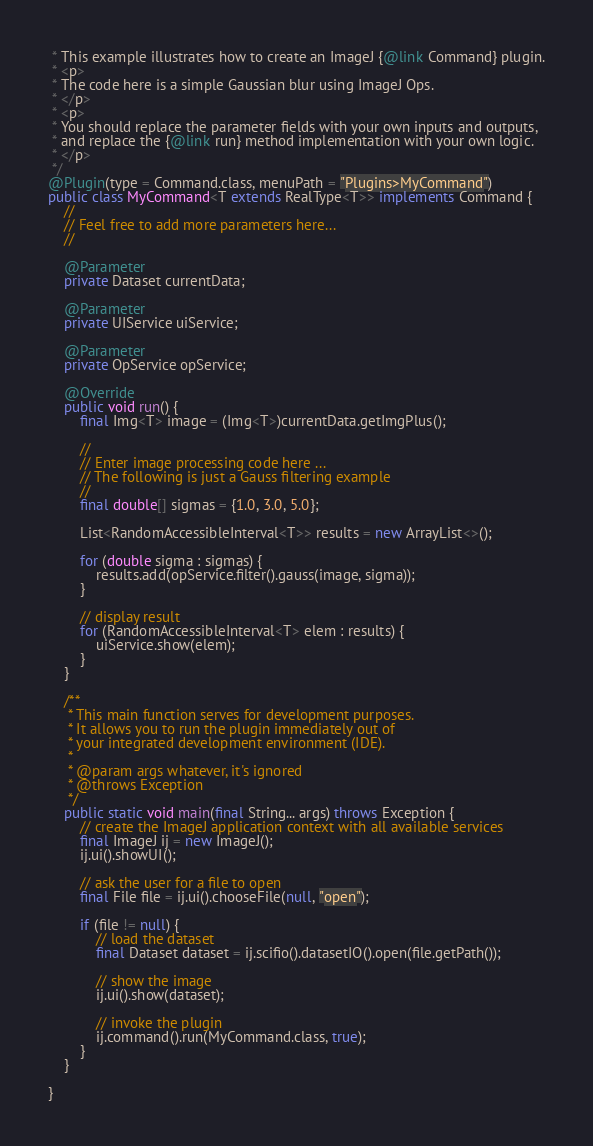Convert code to text. <code><loc_0><loc_0><loc_500><loc_500><_Java_> * This example illustrates how to create an ImageJ {@link Command} plugin.
 * <p>
 * The code here is a simple Gaussian blur using ImageJ Ops.
 * </p>
 * <p>
 * You should replace the parameter fields with your own inputs and outputs,
 * and replace the {@link run} method implementation with your own logic.
 * </p>
 */
@Plugin(type = Command.class, menuPath = "Plugins>MyCommand")
public class MyCommand<T extends RealType<T>> implements Command {
    //
    // Feel free to add more parameters here...
    //

    @Parameter
    private Dataset currentData;

    @Parameter
    private UIService uiService;

    @Parameter
    private OpService opService;

    @Override
    public void run() {
        final Img<T> image = (Img<T>)currentData.getImgPlus();

        //
        // Enter image processing code here ...
        // The following is just a Gauss filtering example
        //
        final double[] sigmas = {1.0, 3.0, 5.0};

        List<RandomAccessibleInterval<T>> results = new ArrayList<>();

        for (double sigma : sigmas) {
            results.add(opService.filter().gauss(image, sigma));
        }

        // display result
        for (RandomAccessibleInterval<T> elem : results) {
            uiService.show(elem);
        }
    }

    /**
     * This main function serves for development purposes.
     * It allows you to run the plugin immediately out of
     * your integrated development environment (IDE).
     *
     * @param args whatever, it's ignored
     * @throws Exception
     */
    public static void main(final String... args) throws Exception {
        // create the ImageJ application context with all available services
        final ImageJ ij = new ImageJ();
        ij.ui().showUI();

        // ask the user for a file to open
        final File file = ij.ui().chooseFile(null, "open");

        if (file != null) {
            // load the dataset
            final Dataset dataset = ij.scifio().datasetIO().open(file.getPath());

            // show the image
            ij.ui().show(dataset);

            // invoke the plugin
            ij.command().run(MyCommand.class, true);
        }
    }

}
</code> 